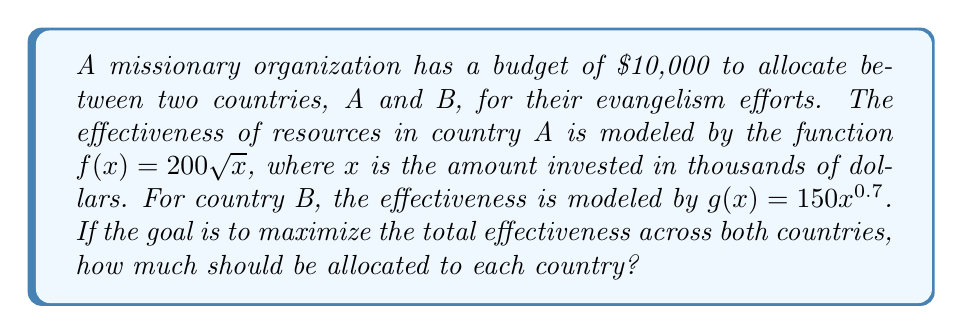Teach me how to tackle this problem. 1) Let x be the amount allocated to country A in thousands of dollars. Then (10-x) will be allocated to country B.

2) The total effectiveness function E(x) is:
   $$E(x) = f(x) + g(10-x) = 200\sqrt{x} + 150(10-x)^{0.7}$$

3) To maximize E(x), we need to find where its derivative equals zero:
   $$E'(x) = \frac{200}{2\sqrt{x}} - 150 \cdot 0.7(10-x)^{-0.3} = 0$$

4) Simplify:
   $$\frac{100}{\sqrt{x}} = 105(10-x)^{-0.3}$$

5) Square both sides:
   $$\frac{10000}{x} = 11025(10-x)^{-0.6}$$

6) Take the reciprocal of both sides:
   $$\frac{x}{10000} = \frac{1}{11025}(10-x)^{0.6}$$

7) Multiply both sides by 10000:
   $$x = \frac{10000}{11025}(10-x)^{0.6}$$

8) This equation can't be solved algebraically. Using numerical methods, we find x ≈ 5.8739.

9) Therefore, approximately $5,873.90 should be allocated to country A, and the remaining $4,126.10 to country B.
Answer: $5,873.90 to country A, $4,126.10 to country B 